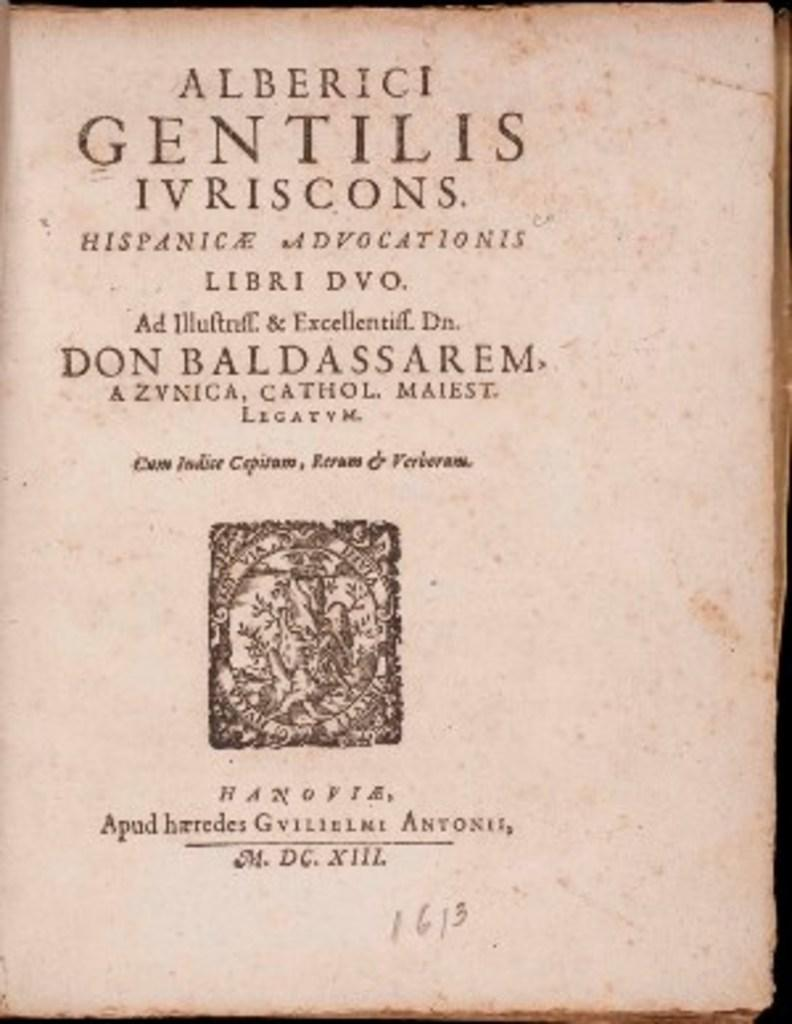<image>
Present a compact description of the photo's key features. A page of Latin text says 1613 on the bottom. 